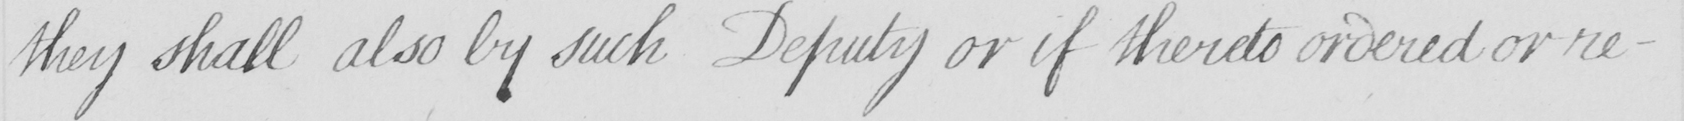Can you read and transcribe this handwriting? they shall also by such Deputy or if thereto ordered or re- 